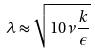Convert formula to latex. <formula><loc_0><loc_0><loc_500><loc_500>\lambda \approx \sqrt { 1 0 \nu \frac { k } { \epsilon } }</formula> 